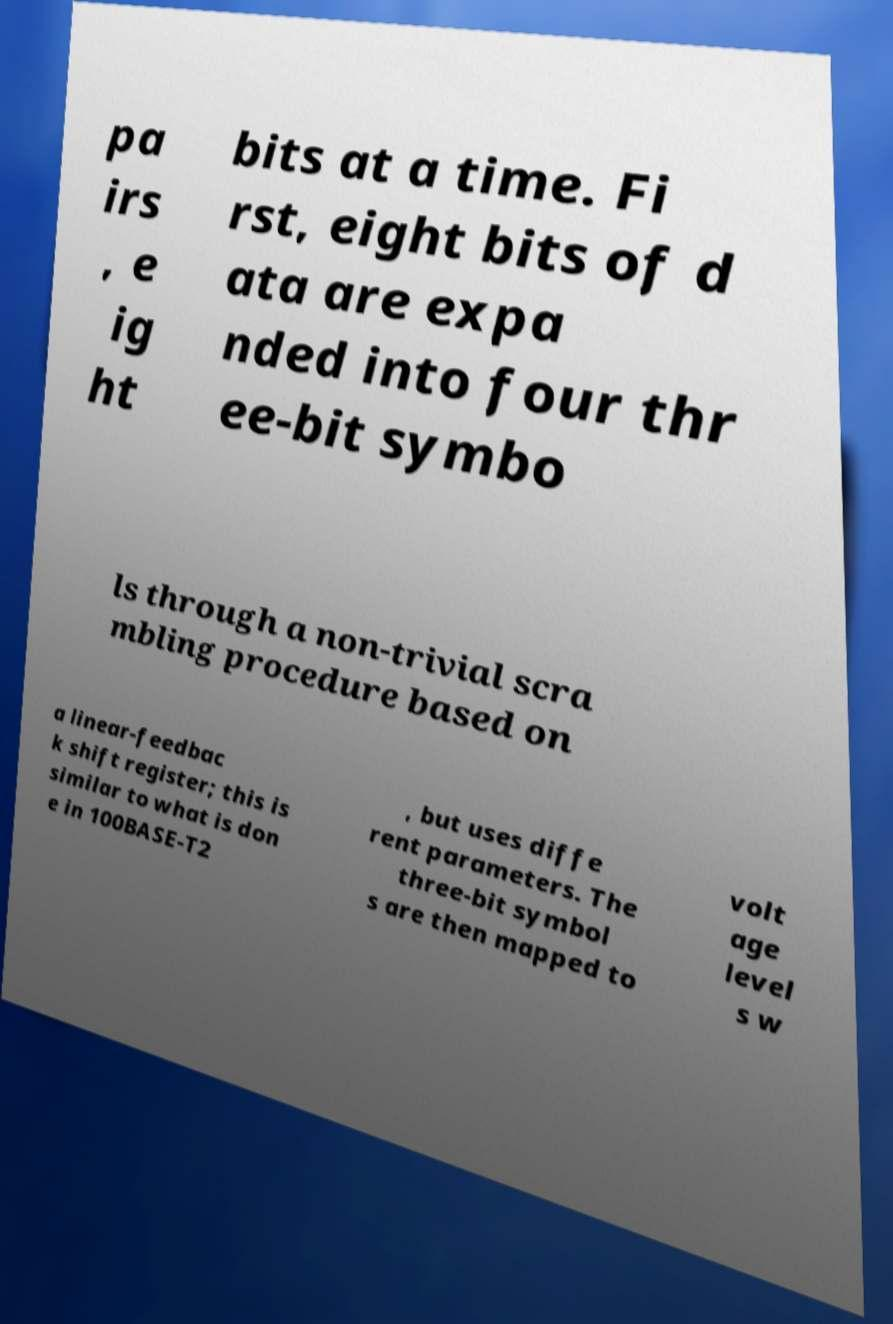Please read and relay the text visible in this image. What does it say? pa irs , e ig ht bits at a time. Fi rst, eight bits of d ata are expa nded into four thr ee-bit symbo ls through a non-trivial scra mbling procedure based on a linear-feedbac k shift register; this is similar to what is don e in 100BASE-T2 , but uses diffe rent parameters. The three-bit symbol s are then mapped to volt age level s w 